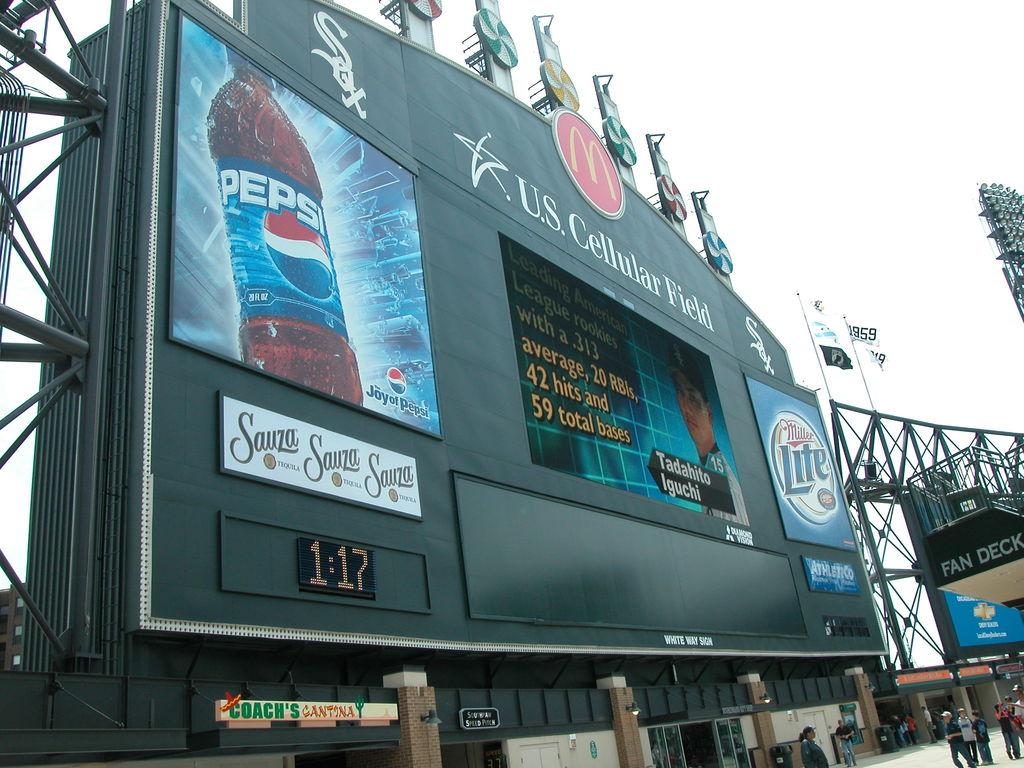What time is it?
Offer a terse response. 1:17. 